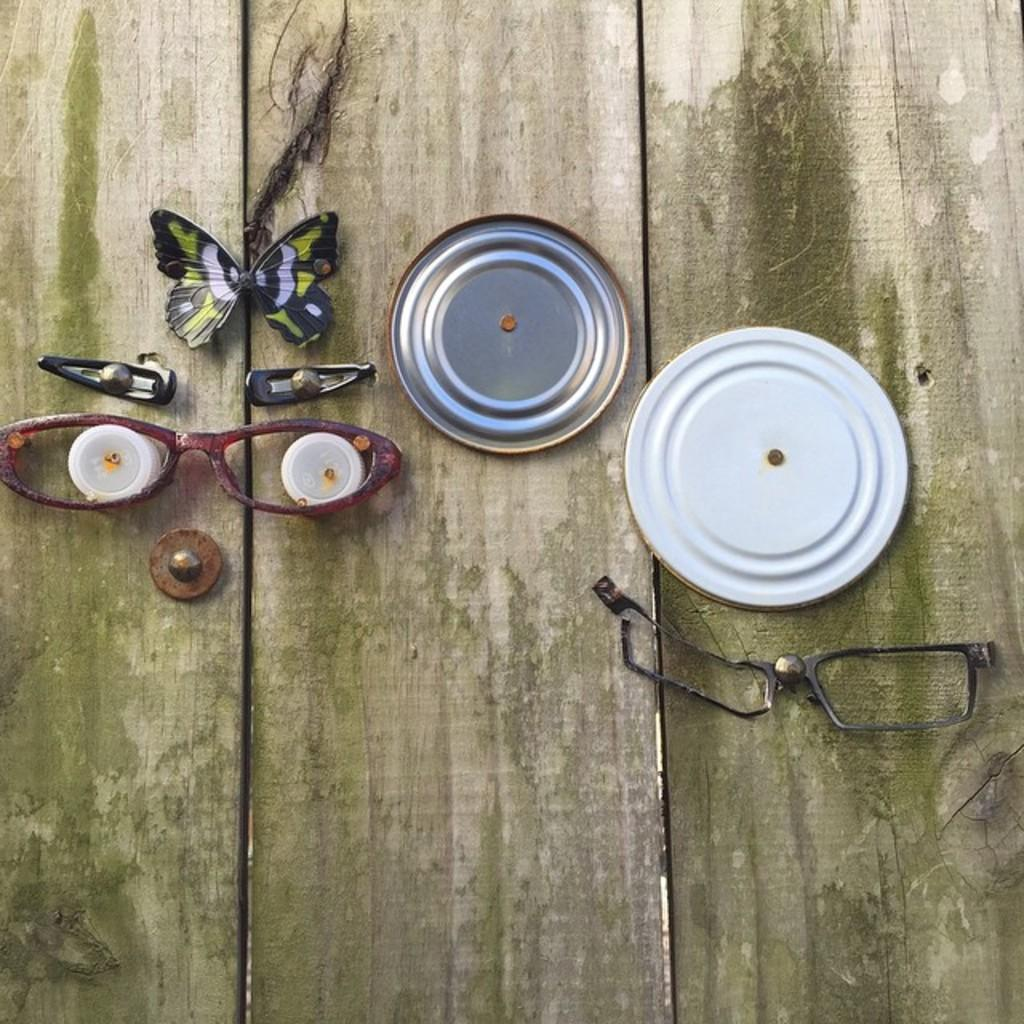What type of table is in the image? There is a wooden table in the image. What feature can be seen on the table? The table has clips on it. What living creature is present in the image? There is a butterfly in the image. What else can be found on the table besides the butterfly? There are other objects on the table. How much money is being discussed by the committee in the image? There is no mention of money or a committee in the image; it features a wooden table with clips, a butterfly, and other objects. What type of gold is being used to decorate the table in the image? There is no gold present in the image; the table is made of wood and has clips on it. 